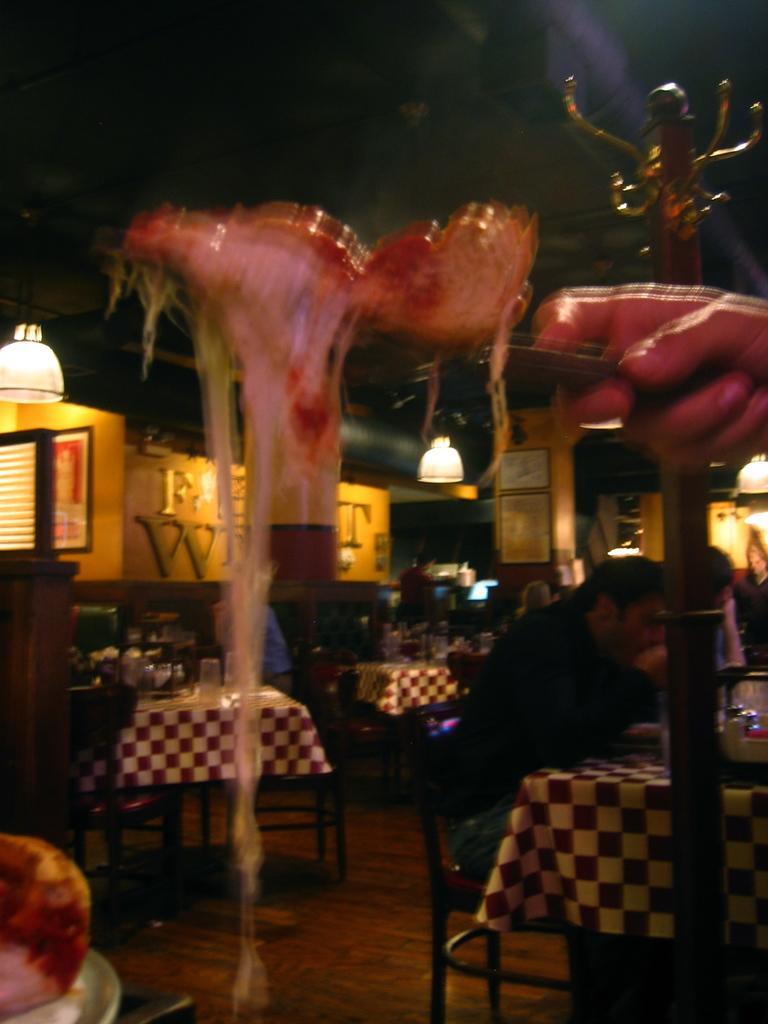In one or two sentences, can you explain what this image depicts? In this image we can see a person holding serving plate with food in it, persons sitting on the chairs and tables are placed in front of them. On the tables we can see cutlery, crockery and serving plates with food in them. In the background there are electric lights hanging from the top. 